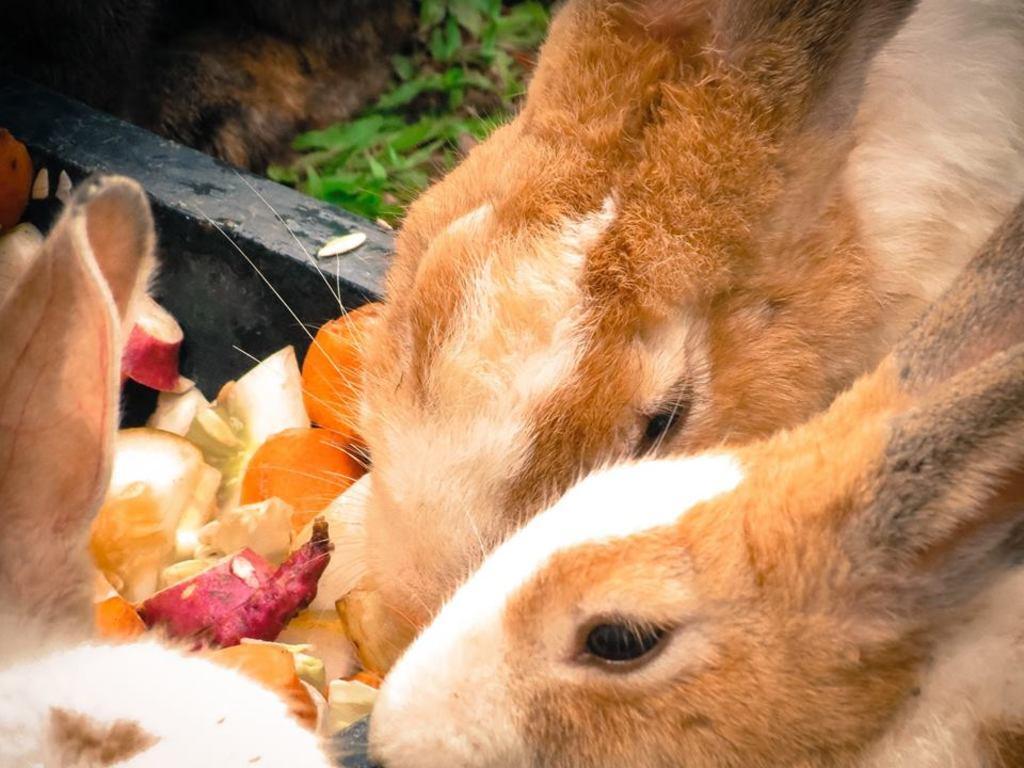Please provide a concise description of this image. In the image, here are few rabbits eating some food and behind the rabbits there is a grass on the ground. 